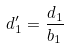<formula> <loc_0><loc_0><loc_500><loc_500>d _ { 1 } ^ { \prime } = \frac { d _ { 1 } } { b _ { 1 } }</formula> 